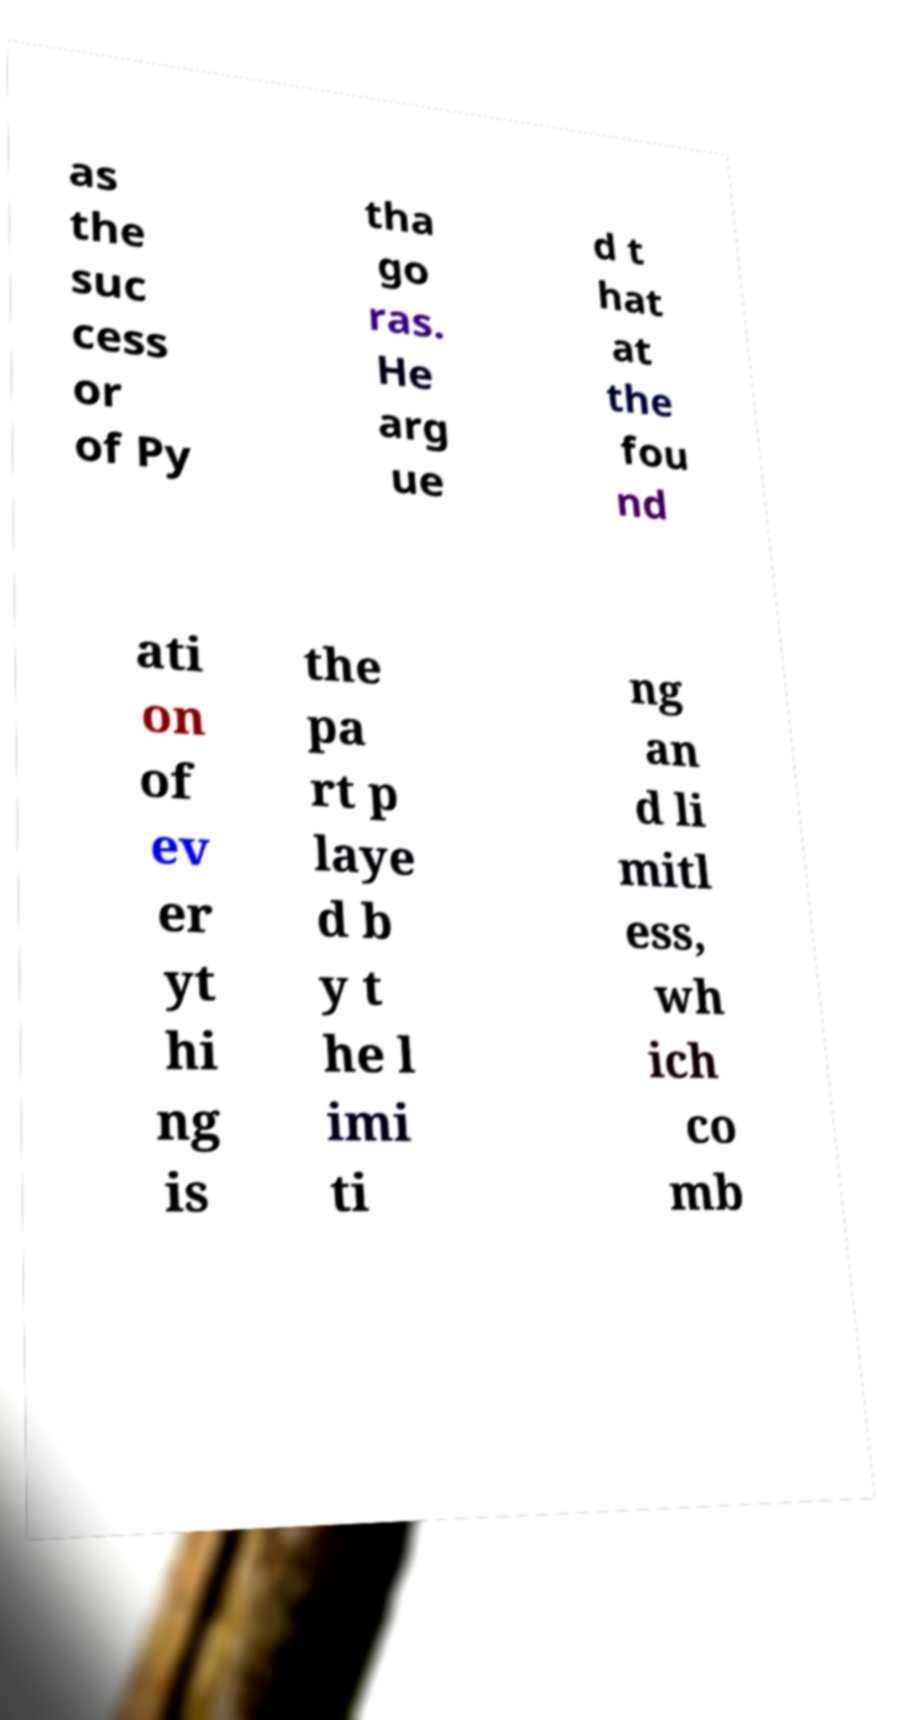Can you read and provide the text displayed in the image?This photo seems to have some interesting text. Can you extract and type it out for me? as the suc cess or of Py tha go ras. He arg ue d t hat at the fou nd ati on of ev er yt hi ng is the pa rt p laye d b y t he l imi ti ng an d li mitl ess, wh ich co mb 